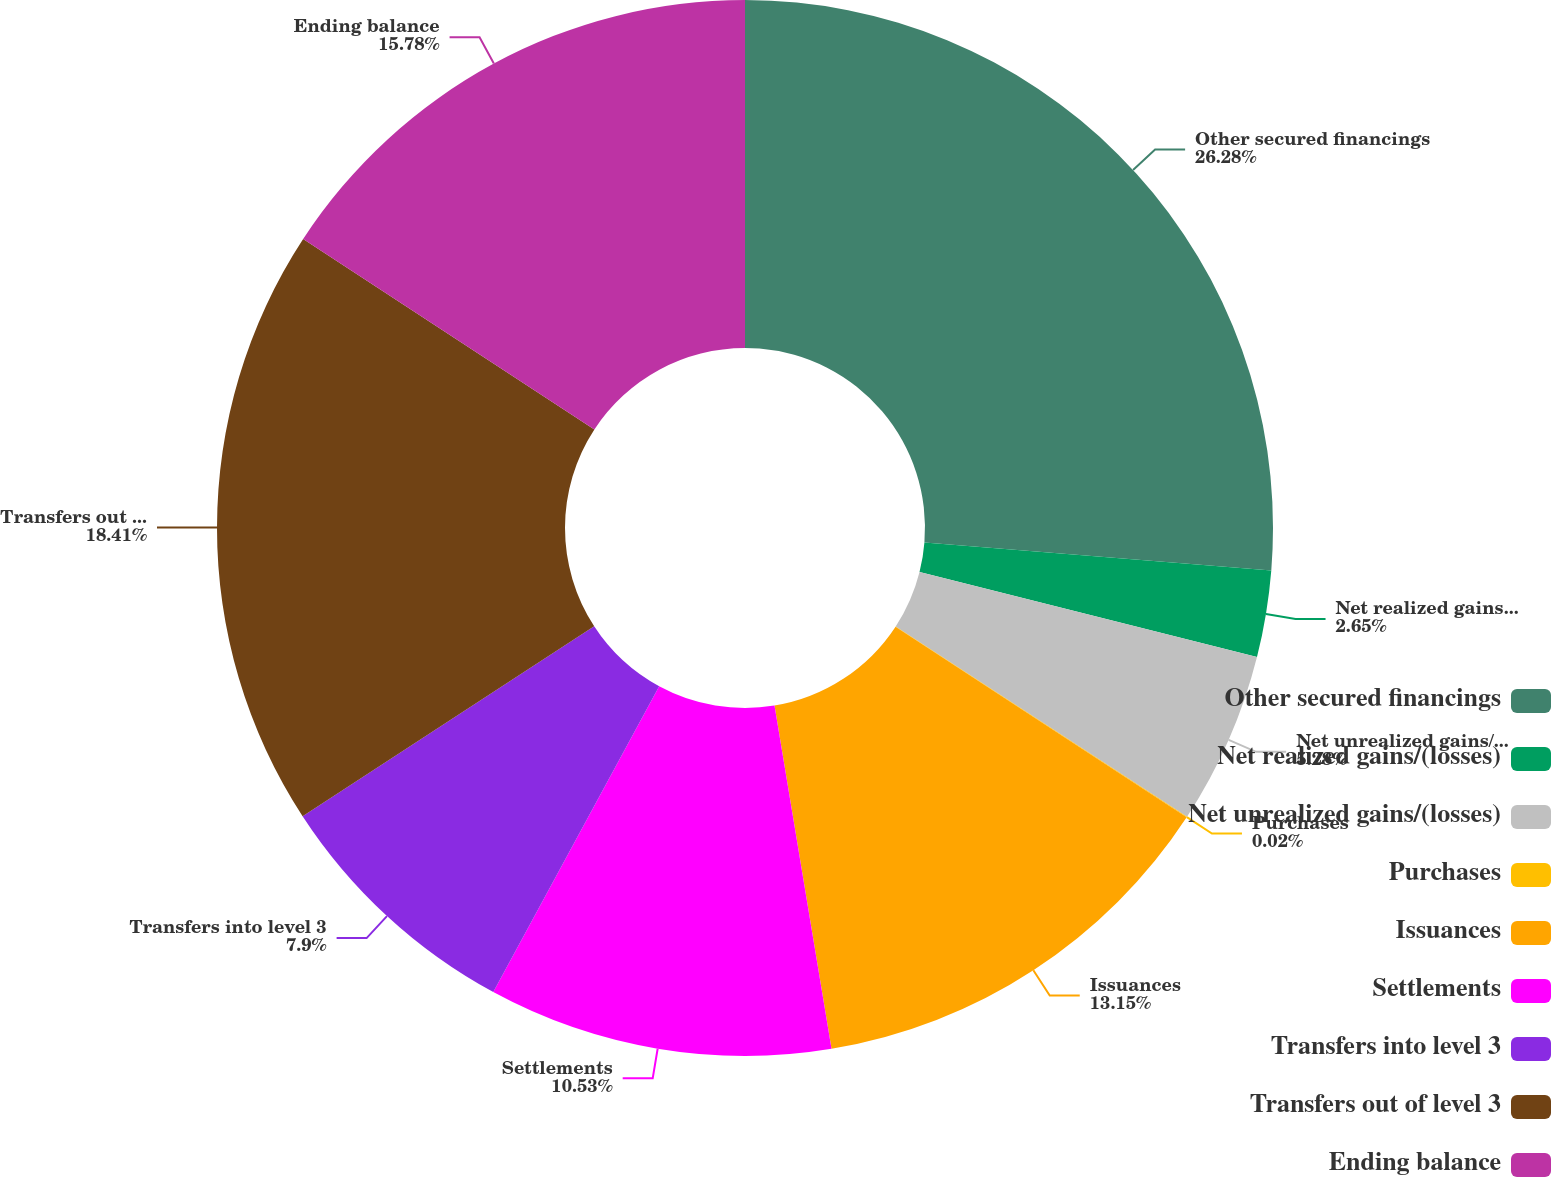Convert chart to OTSL. <chart><loc_0><loc_0><loc_500><loc_500><pie_chart><fcel>Other secured financings<fcel>Net realized gains/(losses)<fcel>Net unrealized gains/(losses)<fcel>Purchases<fcel>Issuances<fcel>Settlements<fcel>Transfers into level 3<fcel>Transfers out of level 3<fcel>Ending balance<nl><fcel>26.28%<fcel>2.65%<fcel>5.28%<fcel>0.02%<fcel>13.15%<fcel>10.53%<fcel>7.9%<fcel>18.41%<fcel>15.78%<nl></chart> 